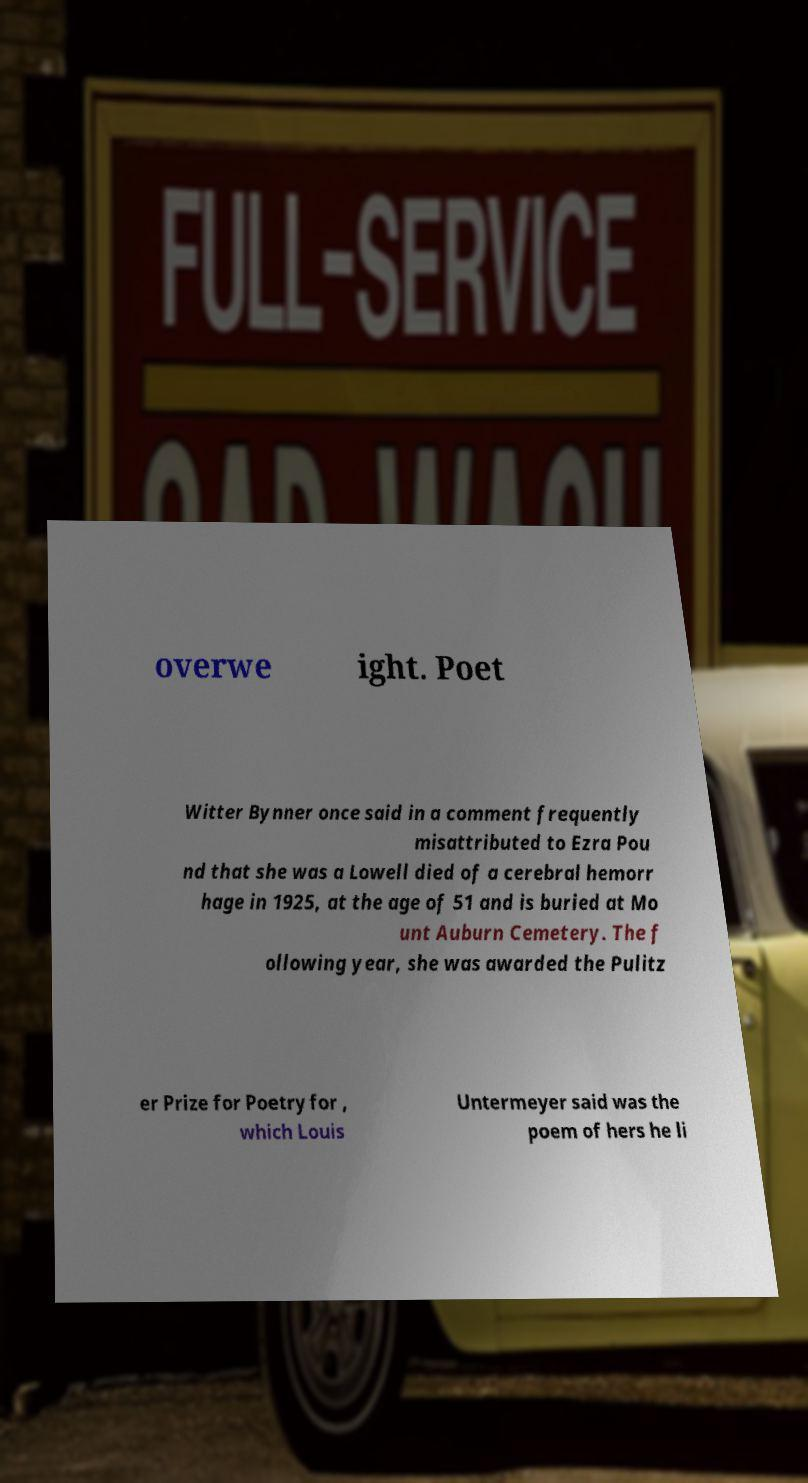What messages or text are displayed in this image? I need them in a readable, typed format. overwe ight. Poet Witter Bynner once said in a comment frequently misattributed to Ezra Pou nd that she was a Lowell died of a cerebral hemorr hage in 1925, at the age of 51 and is buried at Mo unt Auburn Cemetery. The f ollowing year, she was awarded the Pulitz er Prize for Poetry for , which Louis Untermeyer said was the poem of hers he li 